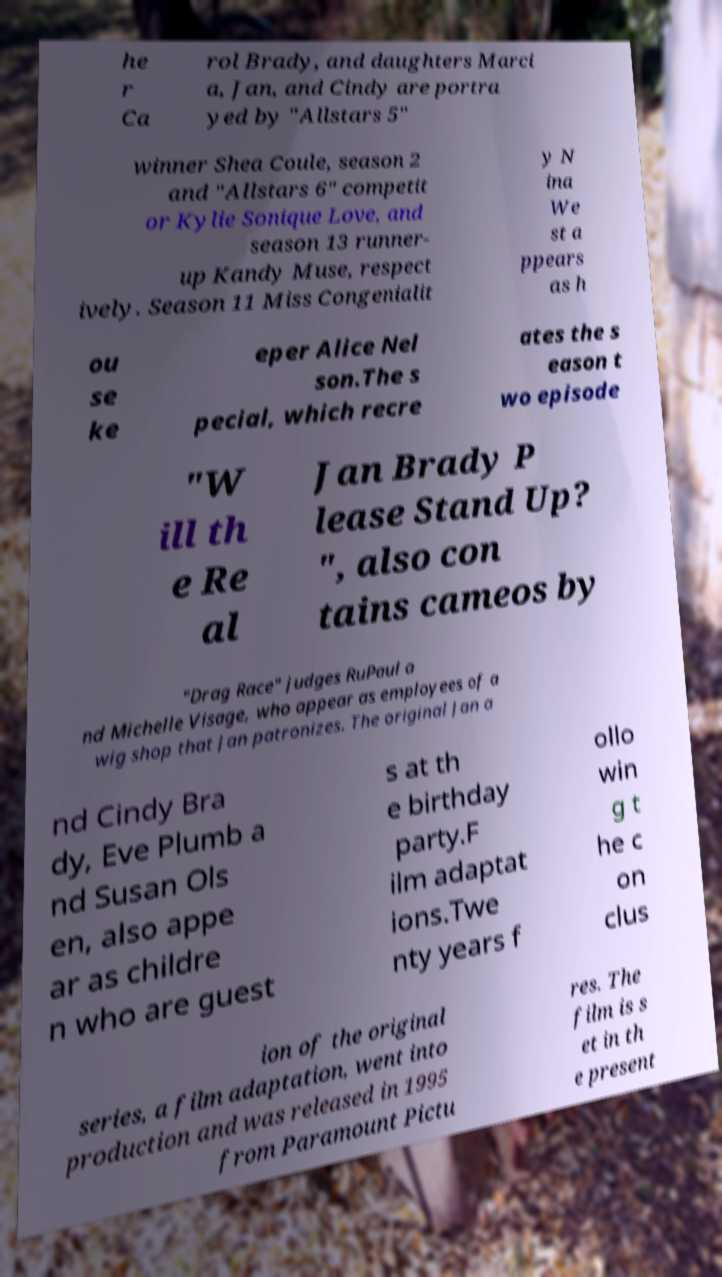Can you read and provide the text displayed in the image?This photo seems to have some interesting text. Can you extract and type it out for me? he r Ca rol Brady, and daughters Marci a, Jan, and Cindy are portra yed by "Allstars 5" winner Shea Coule, season 2 and "Allstars 6" competit or Kylie Sonique Love, and season 13 runner- up Kandy Muse, respect ively. Season 11 Miss Congenialit y N ina We st a ppears as h ou se ke eper Alice Nel son.The s pecial, which recre ates the s eason t wo episode "W ill th e Re al Jan Brady P lease Stand Up? ", also con tains cameos by "Drag Race" judges RuPaul a nd Michelle Visage, who appear as employees of a wig shop that Jan patronizes. The original Jan a nd Cindy Bra dy, Eve Plumb a nd Susan Ols en, also appe ar as childre n who are guest s at th e birthday party.F ilm adaptat ions.Twe nty years f ollo win g t he c on clus ion of the original series, a film adaptation, went into production and was released in 1995 from Paramount Pictu res. The film is s et in th e present 